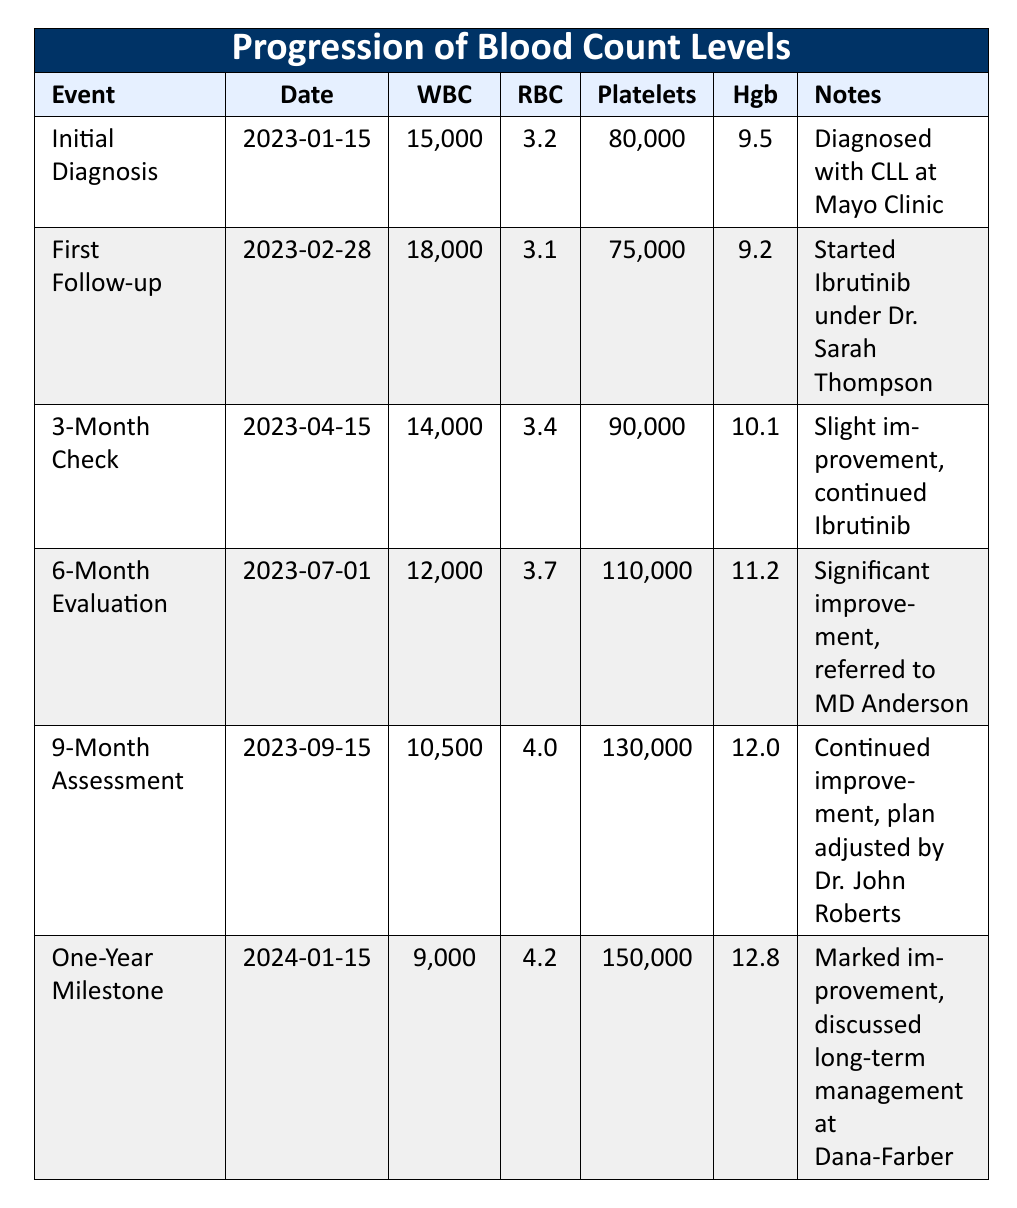What were the white blood cell counts at the initial diagnosis and the one-year milestone? The white blood cell count at the initial diagnosis on January 15, 2023, is 15,000, and at the one-year milestone on January 15, 2024, it is 9,000.
Answer: 15,000 and 9,000 Did the hemoglobin level increase over the first year? By comparing the hemoglobin levels, it can be seen that it was 9.5 at the initial diagnosis and increased to 12.8 at the one-year milestone.
Answer: Yes What is the difference in platelet counts between the initial diagnosis and the 9-month assessment? The platelet count at the initial diagnosis is 80,000, while at the 9-month assessment, it is 130,000. The difference is 130,000 - 80,000, which equals 50,000.
Answer: 50,000 What was the average red blood cell count over the first year? The red blood cell counts in the timeline are 3.2, 3.1, 3.4, 3.7, 4.0, and 4.2. To find the average, we add these values together: 3.2 + 3.1 + 3.4 + 3.7 + 4.0 + 4.2 = 21.6. There are 6 values, so the average is 21.6 / 6 = 3.6.
Answer: 3.6 Was there any day during the year when the white blood cell count was below 10,000? From the data, the lowest white blood cell count was 9,000 at the one-year milestone. Thus, it was below 10,000 on that day.
Answer: Yes What is the trend observed in platelet counts throughout the first year? By examining the platelet counts, they increase from 80,000 at diagnosis to 150,000 at the one-year milestone. This shows a trend of improvement in platelet counts.
Answer: Platelet counts improved 